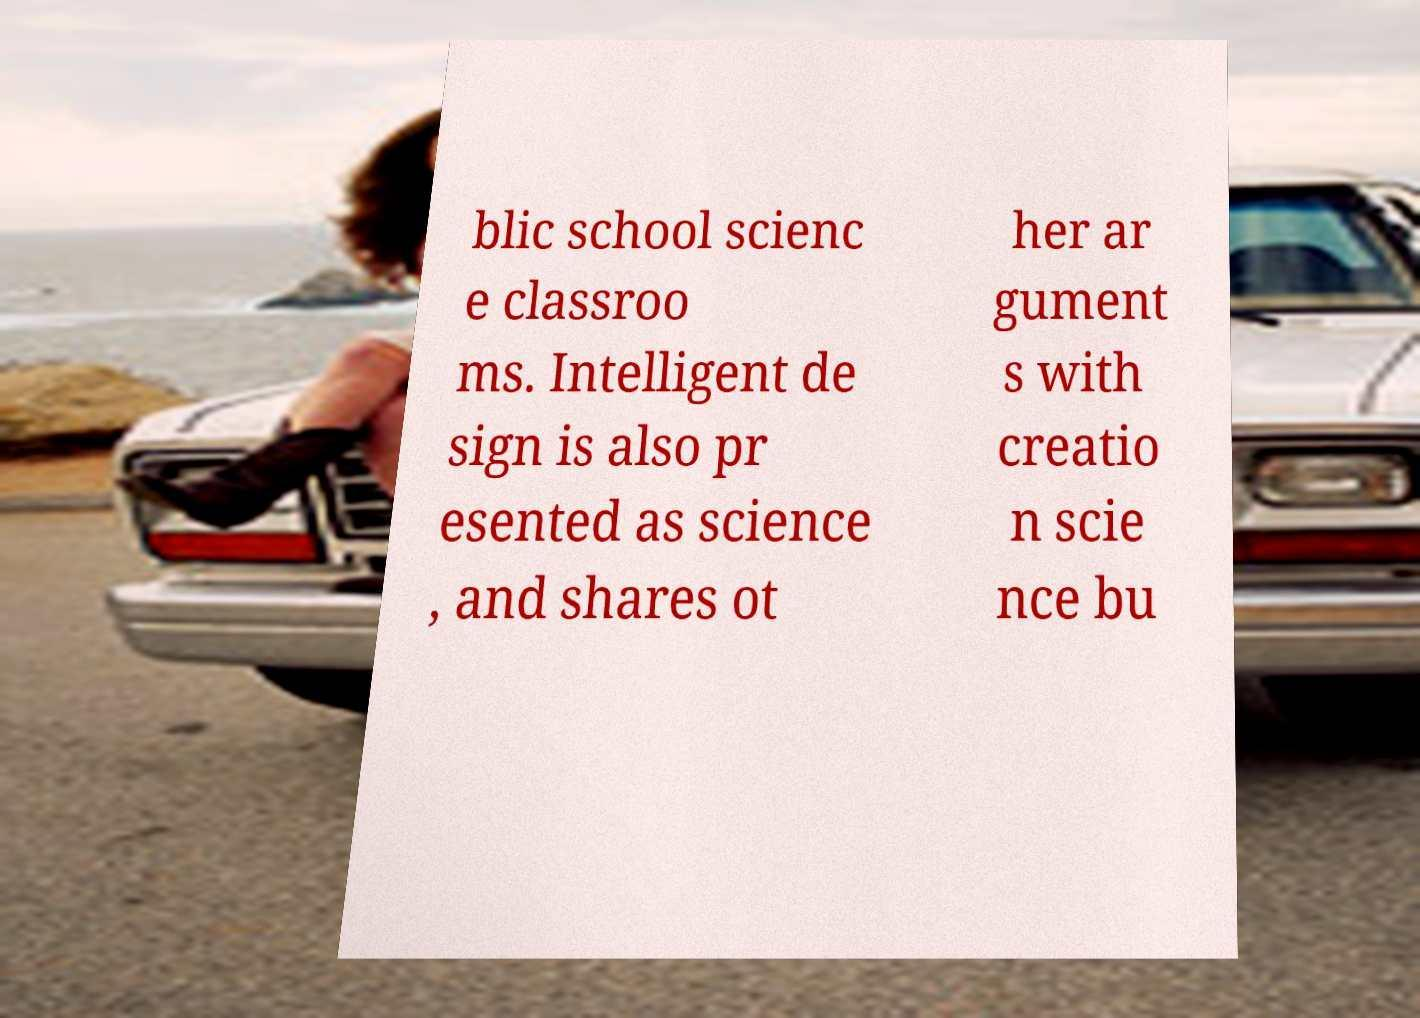Could you extract and type out the text from this image? blic school scienc e classroo ms. Intelligent de sign is also pr esented as science , and shares ot her ar gument s with creatio n scie nce bu 